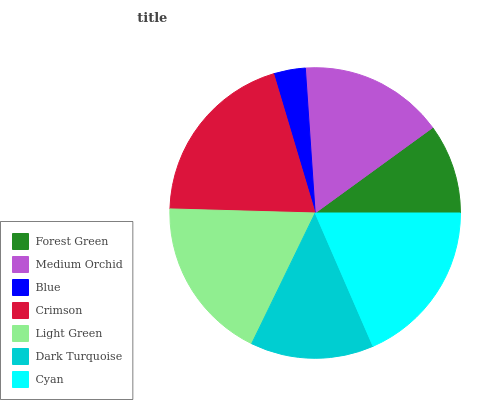Is Blue the minimum?
Answer yes or no. Yes. Is Crimson the maximum?
Answer yes or no. Yes. Is Medium Orchid the minimum?
Answer yes or no. No. Is Medium Orchid the maximum?
Answer yes or no. No. Is Medium Orchid greater than Forest Green?
Answer yes or no. Yes. Is Forest Green less than Medium Orchid?
Answer yes or no. Yes. Is Forest Green greater than Medium Orchid?
Answer yes or no. No. Is Medium Orchid less than Forest Green?
Answer yes or no. No. Is Medium Orchid the high median?
Answer yes or no. Yes. Is Medium Orchid the low median?
Answer yes or no. Yes. Is Dark Turquoise the high median?
Answer yes or no. No. Is Cyan the low median?
Answer yes or no. No. 